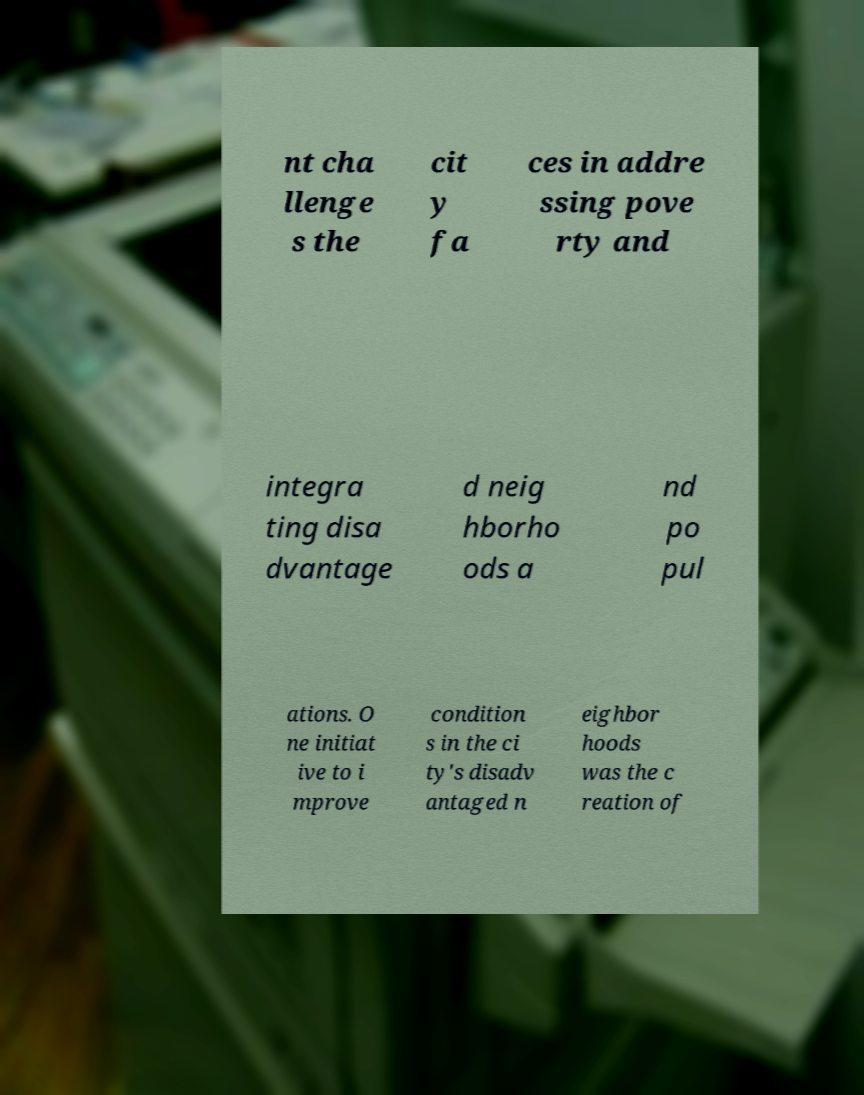For documentation purposes, I need the text within this image transcribed. Could you provide that? nt cha llenge s the cit y fa ces in addre ssing pove rty and integra ting disa dvantage d neig hborho ods a nd po pul ations. O ne initiat ive to i mprove condition s in the ci ty's disadv antaged n eighbor hoods was the c reation of 